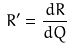<formula> <loc_0><loc_0><loc_500><loc_500>R ^ { \prime } = \frac { d R } { d Q }</formula> 